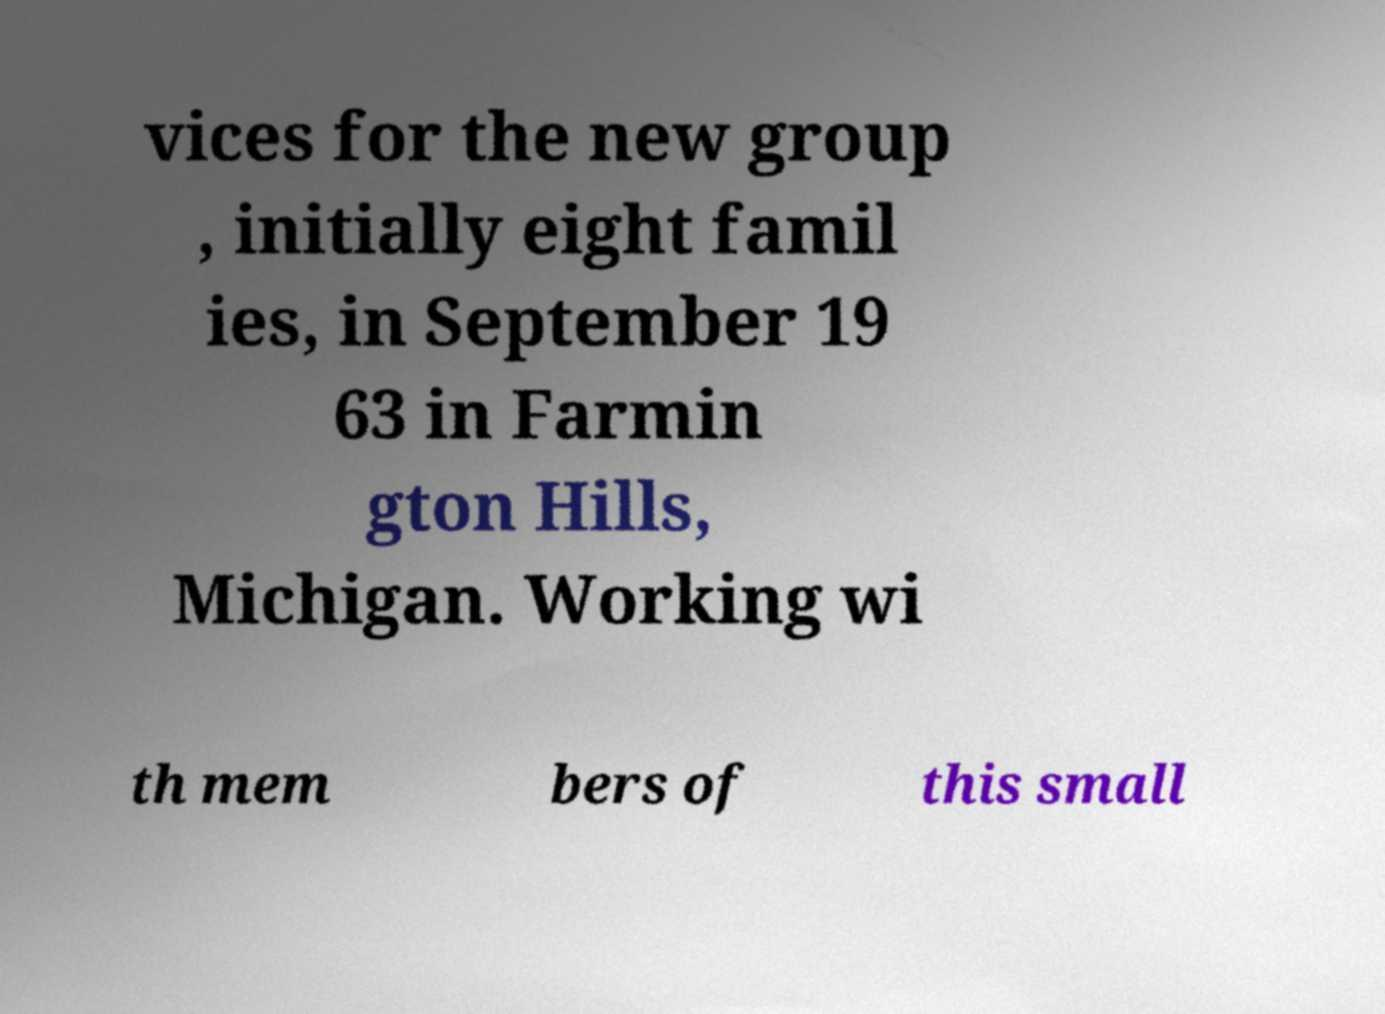Can you read and provide the text displayed in the image?This photo seems to have some interesting text. Can you extract and type it out for me? vices for the new group , initially eight famil ies, in September 19 63 in Farmin gton Hills, Michigan. Working wi th mem bers of this small 